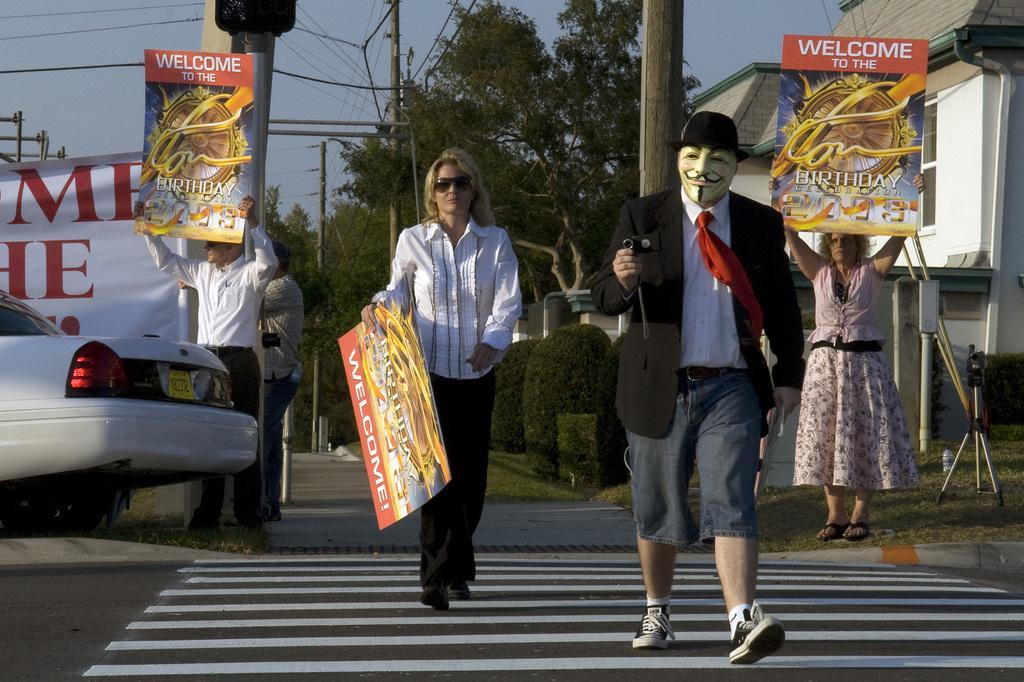In one or two sentences, can you explain what this image depicts? In the foreground of this image, there is a man and a woman holding a poster are walking on the zebra crossing. In the background, there is a man and a woman holding poster and standing. We can also see a banner, trees and a man standing on the road. There are trees, poles, cables and a building in the background. 